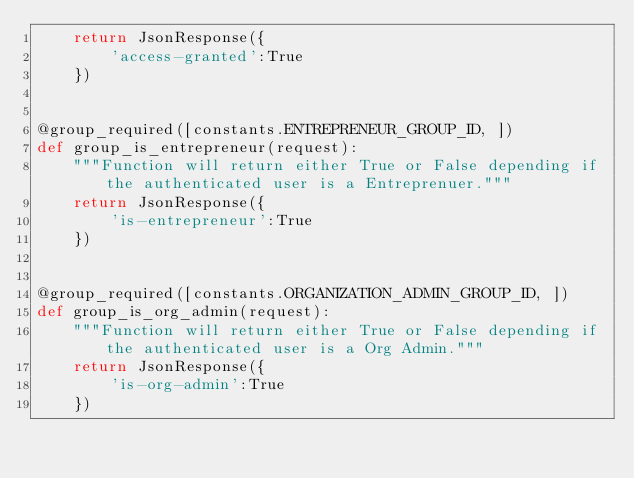<code> <loc_0><loc_0><loc_500><loc_500><_Python_>    return JsonResponse({
        'access-granted':True
    })


@group_required([constants.ENTREPRENEUR_GROUP_ID, ])
def group_is_entrepreneur(request):
    """Function will return either True or False depending if the authenticated user is a Entreprenuer."""
    return JsonResponse({
        'is-entrepreneur':True
    })


@group_required([constants.ORGANIZATION_ADMIN_GROUP_ID, ])
def group_is_org_admin(request):
    """Function will return either True or False depending if the authenticated user is a Org Admin."""
    return JsonResponse({
        'is-org-admin':True
    })
</code> 